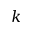<formula> <loc_0><loc_0><loc_500><loc_500>k</formula> 